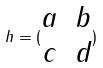<formula> <loc_0><loc_0><loc_500><loc_500>h = ( \begin{matrix} a & b \\ c & d \end{matrix} )</formula> 